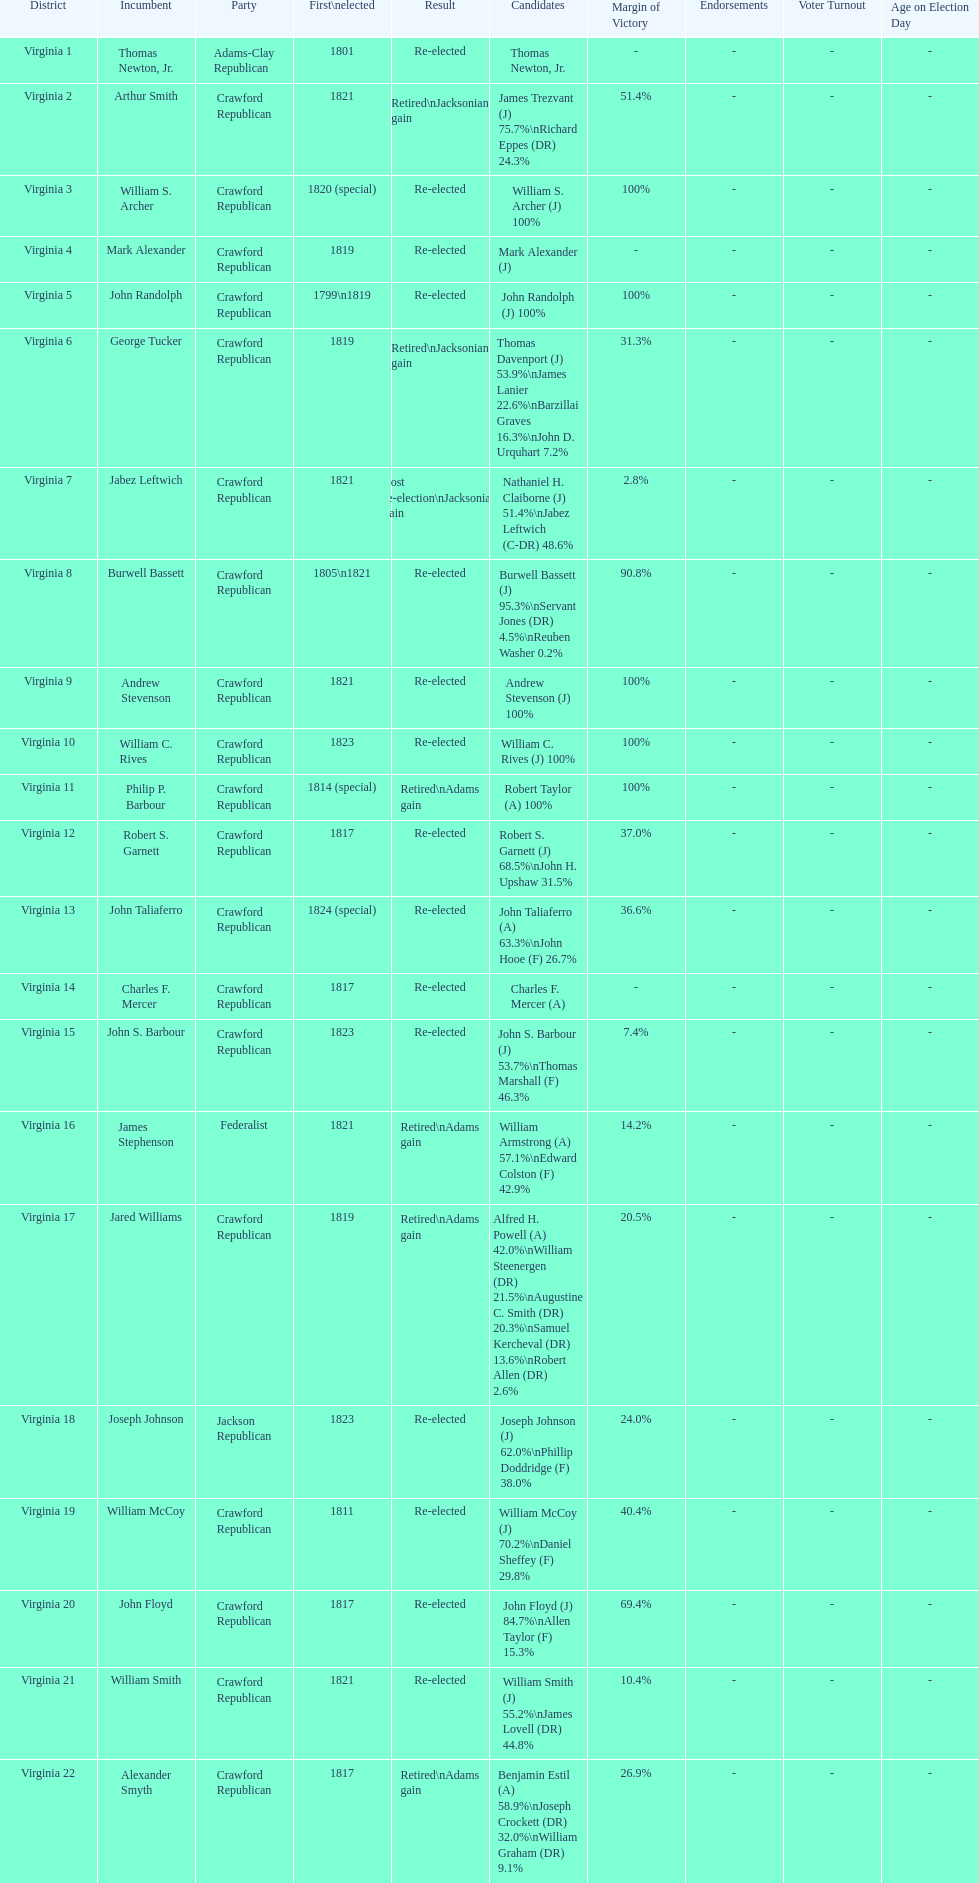Who was the subsequent officeholder following john randolph? George Tucker. I'm looking to parse the entire table for insights. Could you assist me with that? {'header': ['District', 'Incumbent', 'Party', 'First\\nelected', 'Result', 'Candidates', 'Margin of Victory', 'Endorsements', 'Voter Turnout', 'Age on Election Day'], 'rows': [['Virginia 1', 'Thomas Newton, Jr.', 'Adams-Clay Republican', '1801', 'Re-elected', 'Thomas Newton, Jr.', '-', '-', '-', '-'], ['Virginia 2', 'Arthur Smith', 'Crawford Republican', '1821', 'Retired\\nJacksonian gain', 'James Trezvant (J) 75.7%\\nRichard Eppes (DR) 24.3%', '51.4%', '-', '-', '-'], ['Virginia 3', 'William S. Archer', 'Crawford Republican', '1820 (special)', 'Re-elected', 'William S. Archer (J) 100%', '100%', '-', '-', '-'], ['Virginia 4', 'Mark Alexander', 'Crawford Republican', '1819', 'Re-elected', 'Mark Alexander (J)', '-', '-', '-', '-'], ['Virginia 5', 'John Randolph', 'Crawford Republican', '1799\\n1819', 'Re-elected', 'John Randolph (J) 100%', '100%', '-', '-', '-'], ['Virginia 6', 'George Tucker', 'Crawford Republican', '1819', 'Retired\\nJacksonian gain', 'Thomas Davenport (J) 53.9%\\nJames Lanier 22.6%\\nBarzillai Graves 16.3%\\nJohn D. Urquhart 7.2%', '31.3%', '-', '-', '-'], ['Virginia 7', 'Jabez Leftwich', 'Crawford Republican', '1821', 'Lost re-election\\nJacksonian gain', 'Nathaniel H. Claiborne (J) 51.4%\\nJabez Leftwich (C-DR) 48.6%', '2.8%', '-', '-', '-'], ['Virginia 8', 'Burwell Bassett', 'Crawford Republican', '1805\\n1821', 'Re-elected', 'Burwell Bassett (J) 95.3%\\nServant Jones (DR) 4.5%\\nReuben Washer 0.2%', '90.8%', '-', '-', '-'], ['Virginia 9', 'Andrew Stevenson', 'Crawford Republican', '1821', 'Re-elected', 'Andrew Stevenson (J) 100%', '100%', '-', '-', '-'], ['Virginia 10', 'William C. Rives', 'Crawford Republican', '1823', 'Re-elected', 'William C. Rives (J) 100%', '100%', '-', '-', '-'], ['Virginia 11', 'Philip P. Barbour', 'Crawford Republican', '1814 (special)', 'Retired\\nAdams gain', 'Robert Taylor (A) 100%', '100%', '-', '-', '-'], ['Virginia 12', 'Robert S. Garnett', 'Crawford Republican', '1817', 'Re-elected', 'Robert S. Garnett (J) 68.5%\\nJohn H. Upshaw 31.5%', '37.0%', '-', '-', '-'], ['Virginia 13', 'John Taliaferro', 'Crawford Republican', '1824 (special)', 'Re-elected', 'John Taliaferro (A) 63.3%\\nJohn Hooe (F) 26.7%', '36.6%', '-', '-', '-'], ['Virginia 14', 'Charles F. Mercer', 'Crawford Republican', '1817', 'Re-elected', 'Charles F. Mercer (A)', '-', '-', '-', '-'], ['Virginia 15', 'John S. Barbour', 'Crawford Republican', '1823', 'Re-elected', 'John S. Barbour (J) 53.7%\\nThomas Marshall (F) 46.3%', '7.4%', '-', '-', '-'], ['Virginia 16', 'James Stephenson', 'Federalist', '1821', 'Retired\\nAdams gain', 'William Armstrong (A) 57.1%\\nEdward Colston (F) 42.9%', '14.2%', '-', '-', '-'], ['Virginia 17', 'Jared Williams', 'Crawford Republican', '1819', 'Retired\\nAdams gain', 'Alfred H. Powell (A) 42.0%\\nWilliam Steenergen (DR) 21.5%\\nAugustine C. Smith (DR) 20.3%\\nSamuel Kercheval (DR) 13.6%\\nRobert Allen (DR) 2.6%', '20.5%', '-', '-', '-'], ['Virginia 18', 'Joseph Johnson', 'Jackson Republican', '1823', 'Re-elected', 'Joseph Johnson (J) 62.0%\\nPhillip Doddridge (F) 38.0%', '24.0%', '-', '-', '-'], ['Virginia 19', 'William McCoy', 'Crawford Republican', '1811', 'Re-elected', 'William McCoy (J) 70.2%\\nDaniel Sheffey (F) 29.8%', '40.4%', '-', '-', '-'], ['Virginia 20', 'John Floyd', 'Crawford Republican', '1817', 'Re-elected', 'John Floyd (J) 84.7%\\nAllen Taylor (F) 15.3%', '69.4%', '-', '-', '-'], ['Virginia 21', 'William Smith', 'Crawford Republican', '1821', 'Re-elected', 'William Smith (J) 55.2%\\nJames Lovell (DR) 44.8%', '10.4%', '-', '-', '-'], ['Virginia 22', 'Alexander Smyth', 'Crawford Republican', '1817', 'Retired\\nAdams gain', 'Benjamin Estil (A) 58.9%\\nJoseph Crockett (DR) 32.0%\\nWilliam Graham (DR) 9.1%', '26.9%', '-', '-', '-']]} 